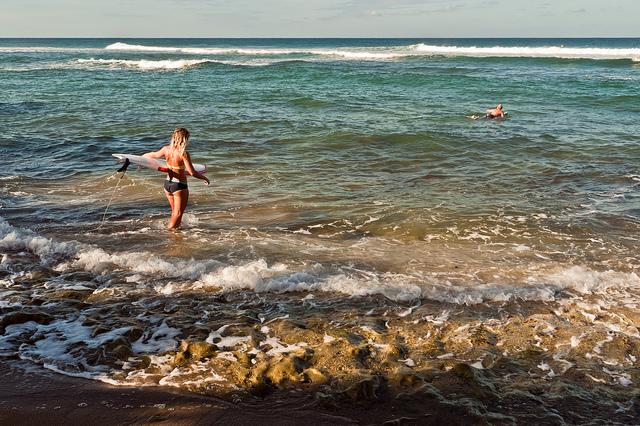How many waves are there?
Concise answer only. 3. What is the woman going to do?
Be succinct. Surf. Is she climbing on a mountain?
Concise answer only. No. 